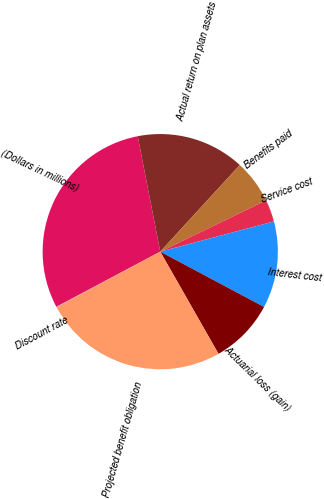Convert chart. <chart><loc_0><loc_0><loc_500><loc_500><pie_chart><fcel>(Dollars in millions)<fcel>Actual return on plan assets<fcel>Benefits paid<fcel>Service cost<fcel>Interest cost<fcel>Actuarial loss (gain)<fcel>Projected benefit obligation<fcel>Discount rate<nl><fcel>29.7%<fcel>14.89%<fcel>6.0%<fcel>3.04%<fcel>11.93%<fcel>8.96%<fcel>25.4%<fcel>0.08%<nl></chart> 